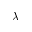Convert formula to latex. <formula><loc_0><loc_0><loc_500><loc_500>\lambda</formula> 